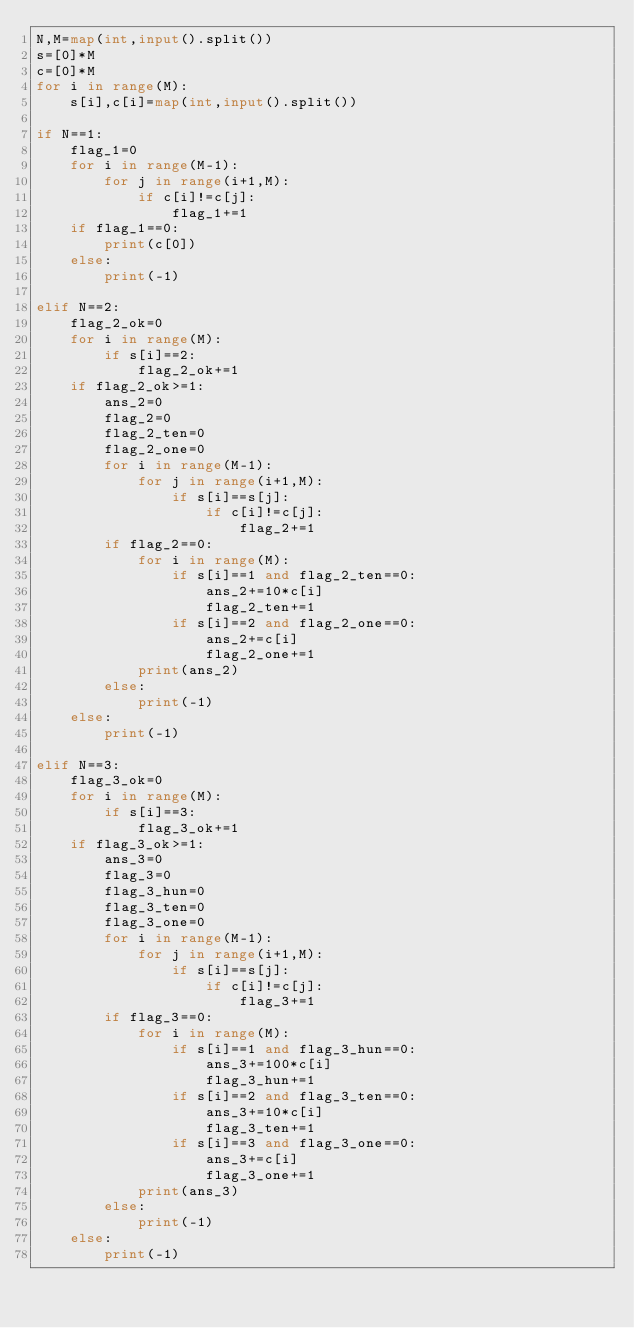Convert code to text. <code><loc_0><loc_0><loc_500><loc_500><_Python_>N,M=map(int,input().split())
s=[0]*M
c=[0]*M
for i in range(M):
    s[i],c[i]=map(int,input().split())
    
if N==1:
    flag_1=0
    for i in range(M-1):
        for j in range(i+1,M):
            if c[i]!=c[j]:
                flag_1+=1
    if flag_1==0:
        print(c[0])
    else:
        print(-1)

elif N==2:
    flag_2_ok=0
    for i in range(M):
        if s[i]==2:
            flag_2_ok+=1
    if flag_2_ok>=1:
        ans_2=0
        flag_2=0
        flag_2_ten=0
        flag_2_one=0
        for i in range(M-1):
            for j in range(i+1,M):
                if s[i]==s[j]:
                    if c[i]!=c[j]:
                        flag_2+=1
        if flag_2==0:
            for i in range(M):
                if s[i]==1 and flag_2_ten==0:
                    ans_2+=10*c[i]
                    flag_2_ten+=1
                if s[i]==2 and flag_2_one==0:
                    ans_2+=c[i]
                    flag_2_one+=1
            print(ans_2)
        else:
            print(-1)
    else:
        print(-1)
        
elif N==3:
    flag_3_ok=0
    for i in range(M):
        if s[i]==3:
            flag_3_ok+=1
    if flag_3_ok>=1:
        ans_3=0
        flag_3=0
        flag_3_hun=0
        flag_3_ten=0
        flag_3_one=0
        for i in range(M-1):
            for j in range(i+1,M):
                if s[i]==s[j]:
                    if c[i]!=c[j]:
                        flag_3+=1
        if flag_3==0:
            for i in range(M):
                if s[i]==1 and flag_3_hun==0:
                    ans_3+=100*c[i]
                    flag_3_hun+=1
                if s[i]==2 and flag_3_ten==0:
                    ans_3+=10*c[i]
                    flag_3_ten+=1
                if s[i]==3 and flag_3_one==0:
                    ans_3+=c[i]
                    flag_3_one+=1
            print(ans_3)
        else:
            print(-1)
    else:
        print(-1)</code> 